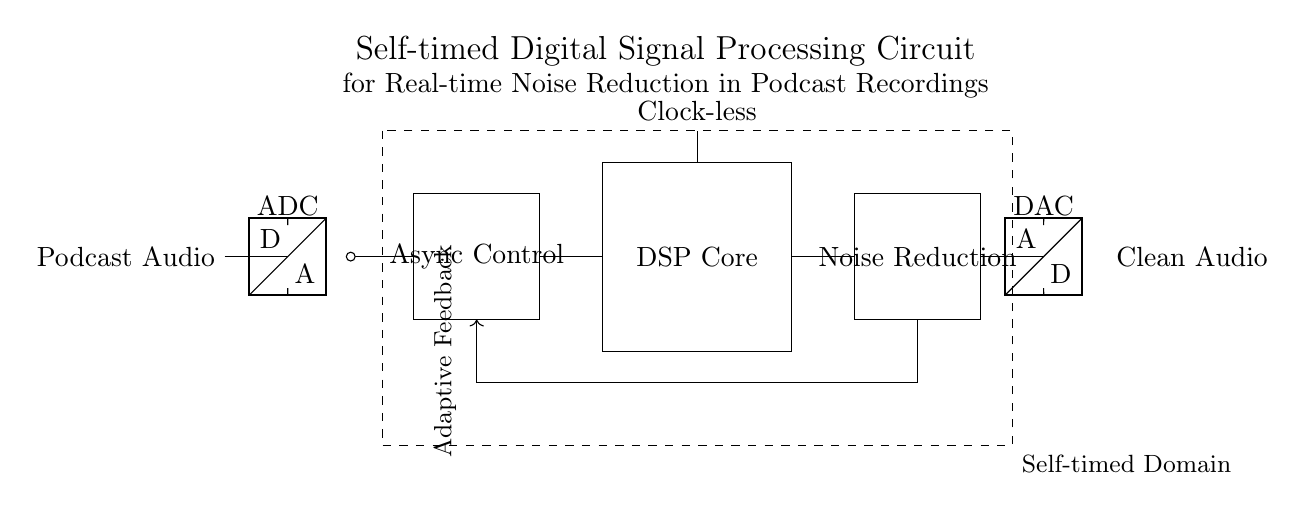What component converts the podcast audio signal to a digital signal? The component that performs this conversion is the ADC, which is labeled in the circuit. The ADC, or Analog-to-Digital Converter, translates the continuous analog audio signal into a discrete digital format.
Answer: ADC What is the purpose of the Async Control block? The Async Control block is responsible for managing the asynchronous timing of the circuit. It ensures that the signal processing occurs without requiring a synchronized clock signal, which is crucial for enhancing efficiency in responsive signal processing contexts.
Answer: Asynchronous timing management How many main functional blocks are present in this circuit diagram? There are three main functional blocks visible in the circuit: the Async Control block, the DSP Core, and the Noise Reduction block. Each block performs a distinct role in processing the audio signal.
Answer: Three What type of signal processing is utilized in the DSP Core? The DSP Core utilizes clock-less processing, which is signified by the 'Clock-less' label in the diagram. This indicates that the processing does not rely on a traditional clock signal, allowing for greater flexibility in processing speeds.
Answer: Clock-less What type of feedback mechanism is indicated in the circuit? The circuit features an Adaptive Feedback mechanism, which allows the system to adjust its processing based on the audio signal characteristics, thus optimizing the noise reduction effectively. This feedback helps improve audio quality in real-time by adapting to the signal.
Answer: Adaptive Feedback What is the ultimate output produced by the circuit? The ultimate output produced by the circuit is Clean Audio, which is specified on the right side of the circuit. This is the finalized audio signal after processing and noise reduction, intended for the user.
Answer: Clean Audio What does the dashed rectangle represent in the circuit? The dashed rectangle represents the Self-timed Domain, indicating the area where self-timing principles are applied to manage the circuit's operations asynchronously, distinguishing it from traditional synchronous designs.
Answer: Self-timed Domain 